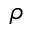Convert formula to latex. <formula><loc_0><loc_0><loc_500><loc_500>\rho</formula> 